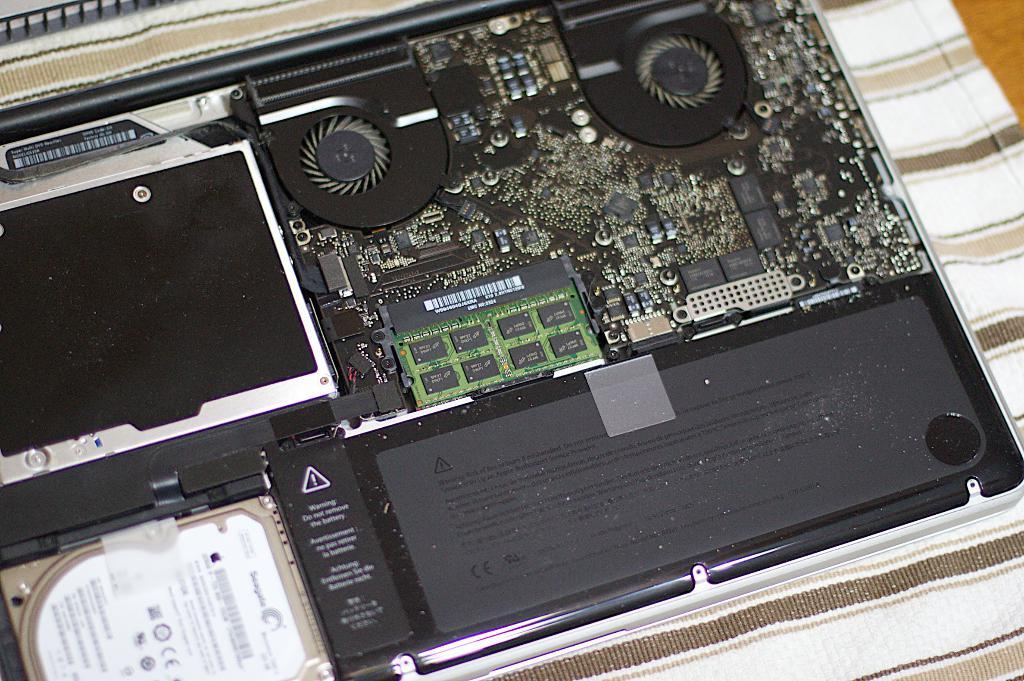<image>
Give a short and clear explanation of the subsequent image. The inside of a computer motherboard that says warning by the triangle 